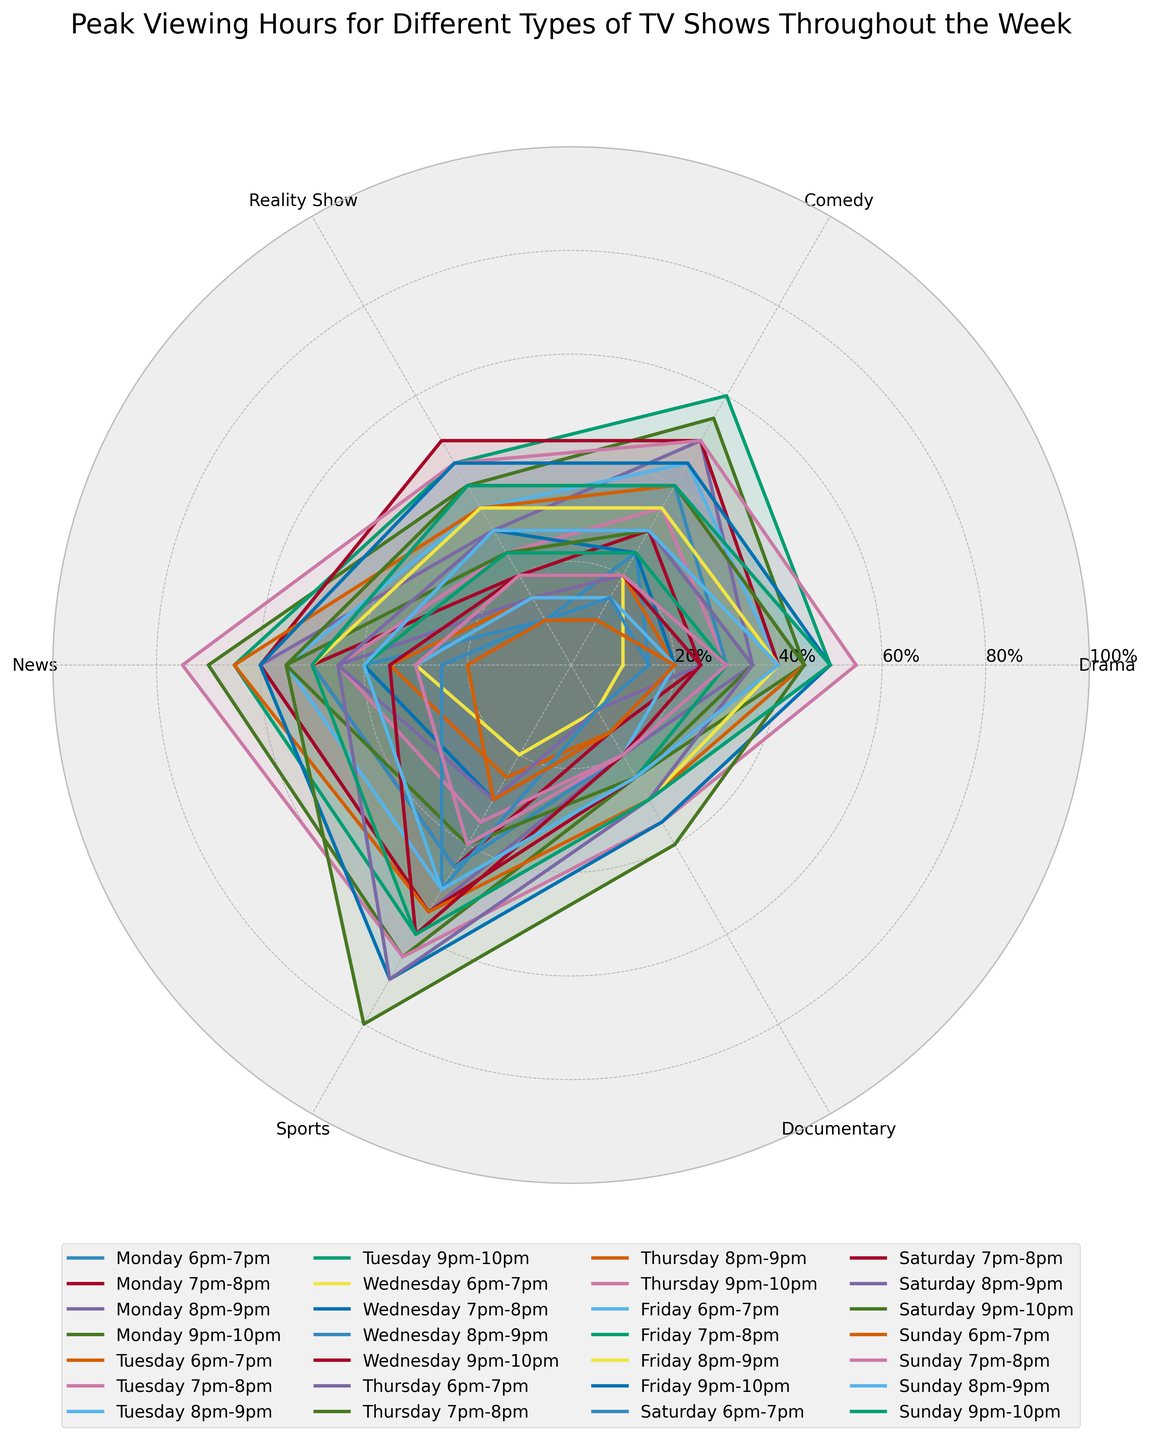What is the title of the figure? The title is usually located at the top of the figure and provides information about the content.
Answer: Peak Viewing Hours for Different Types of TV Shows Throughout the Week Which type of TV show has the highest peak viewing percentage on Thursday from 9pm to 10pm? The line representing Thursday 9pm-10pm and its intersection with the radial grid shows the highest peak in this time slot.
Answer: News Comparing Monday 6pm-7pm and Monday 7pm-8pm, which period has more viewers for Drama shows? Look at the radial distances for Drama on Monday 6pm-7pm and Monday 7pm-8pm. The longer the radial line, the higher the value.
Answer: Monday 7pm-8pm What is the general trend for Sports viewership from Monday to Friday? Examine the positions of the data points for Sports from Monday to Friday and notice whether the values are increasing, decreasing, or showing any pattern.
Answer: Increasing from Monday to Friday On which day and time does Comedy shows reach their peak viewership? Identify the largest radial distance in the Comedy section of the rose chart and note the corresponding day and time.
Answer: Tuesday 9pm-10pm Which type of TV show has the least viewership on Saturday from 6pm to 7pm? Look for the shortest radial distance corresponding to Saturday 6pm-7pm across all types of TV shows.
Answer: Drama Is there a time slot where Reality Shows consistently have higher viewership than Documentaries? Compare the radial lengths of Reality Shows and Documentaries for each time slot. Look for time slots where Reality Shows always have a longer radial length.
Answer: Yes, all time slots How does News viewership on Sundays compare to other days? Compare the radial distances for News on Sundays against other days to determine if Sundays have higher, lower, or similar values.
Answer: Generally lower What is the average peak viewing percentage for Drama shows on Thursday? Sum the radial distances for Drama on all Thursday time slots and divide by the number of time slots to find the average. (25+35+45+55) / 4 = 40
Answer: 40 How do viewership trends for Comedy and Reality Shows compare from Wednesday 7pm-8pm to 9pm-10pm? Analyze the change in radial distances for Comedy and Reality Shows between these time slots on Wednesday. Calculate the differences to understand the trends.
Answer: Comedy and Reality Shows both increase from 7pm-8pm to 9pm-10pm 